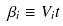Convert formula to latex. <formula><loc_0><loc_0><loc_500><loc_500>\beta _ { i } \equiv V _ { i } t</formula> 